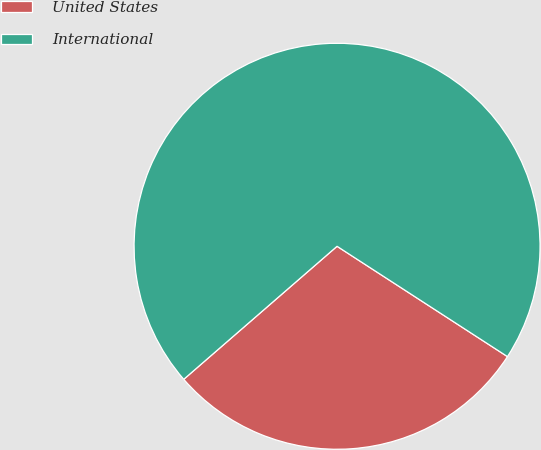<chart> <loc_0><loc_0><loc_500><loc_500><pie_chart><fcel>United States<fcel>International<nl><fcel>29.48%<fcel>70.52%<nl></chart> 